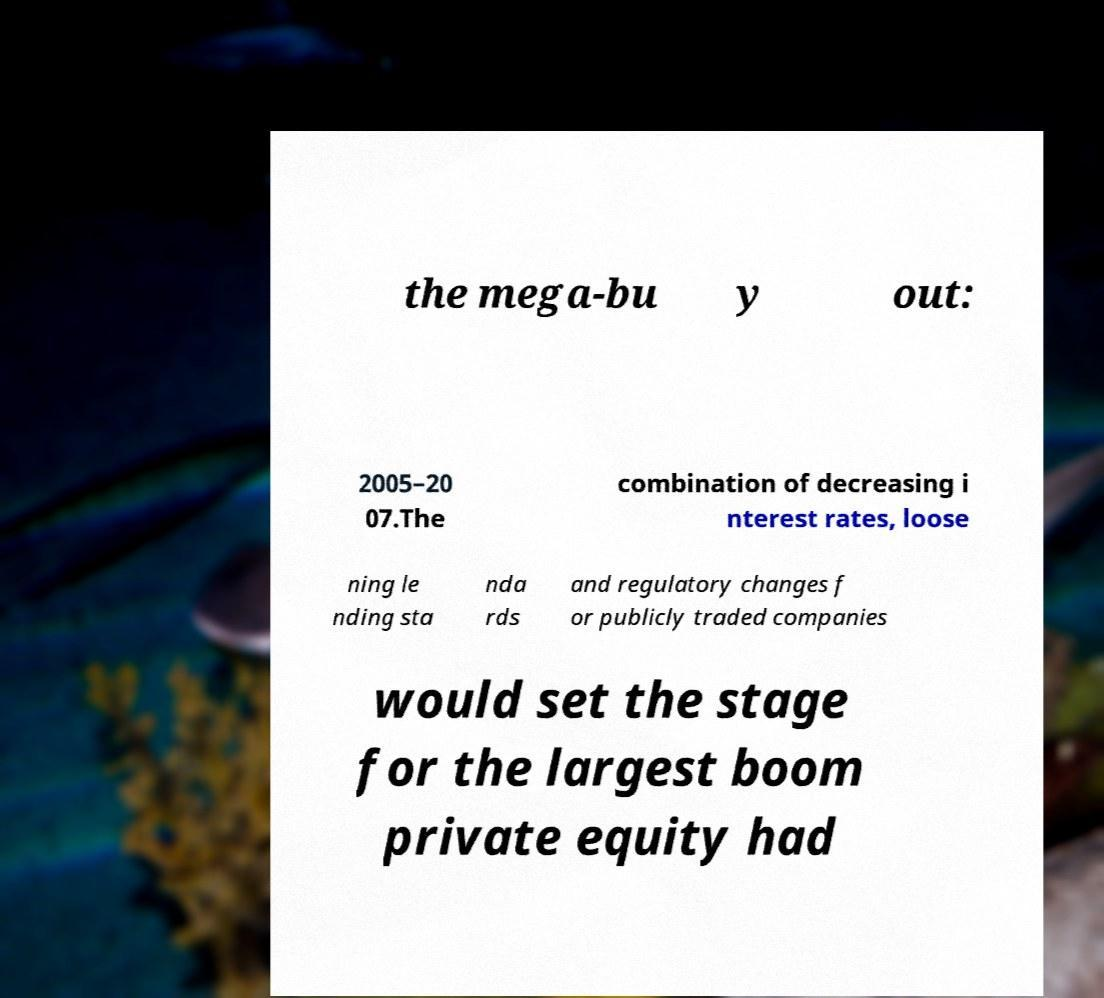I need the written content from this picture converted into text. Can you do that? the mega-bu y out: 2005–20 07.The combination of decreasing i nterest rates, loose ning le nding sta nda rds and regulatory changes f or publicly traded companies would set the stage for the largest boom private equity had 